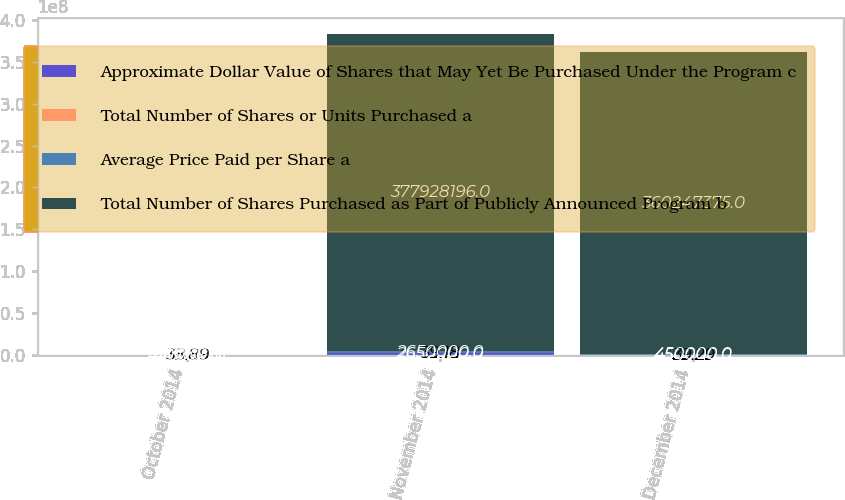<chart> <loc_0><loc_0><loc_500><loc_500><stacked_bar_chart><ecel><fcel>October 2014<fcel>November 2014<fcel>December 2014<nl><fcel>Approximate Dollar Value of Shares that May Yet Be Purchased Under the Program c<fcel>40000<fcel>2.65e+06<fcel>450000<nl><fcel>Total Number of Shares or Units Purchased a<fcel>38.89<fcel>39.18<fcel>39.29<nl><fcel>Average Price Paid per Share a<fcel>40000<fcel>2.65e+06<fcel>450000<nl><fcel>Total Number of Shares Purchased as Part of Publicly Announced Program b<fcel>450000<fcel>3.77928e+08<fcel>3.60247e+08<nl></chart> 